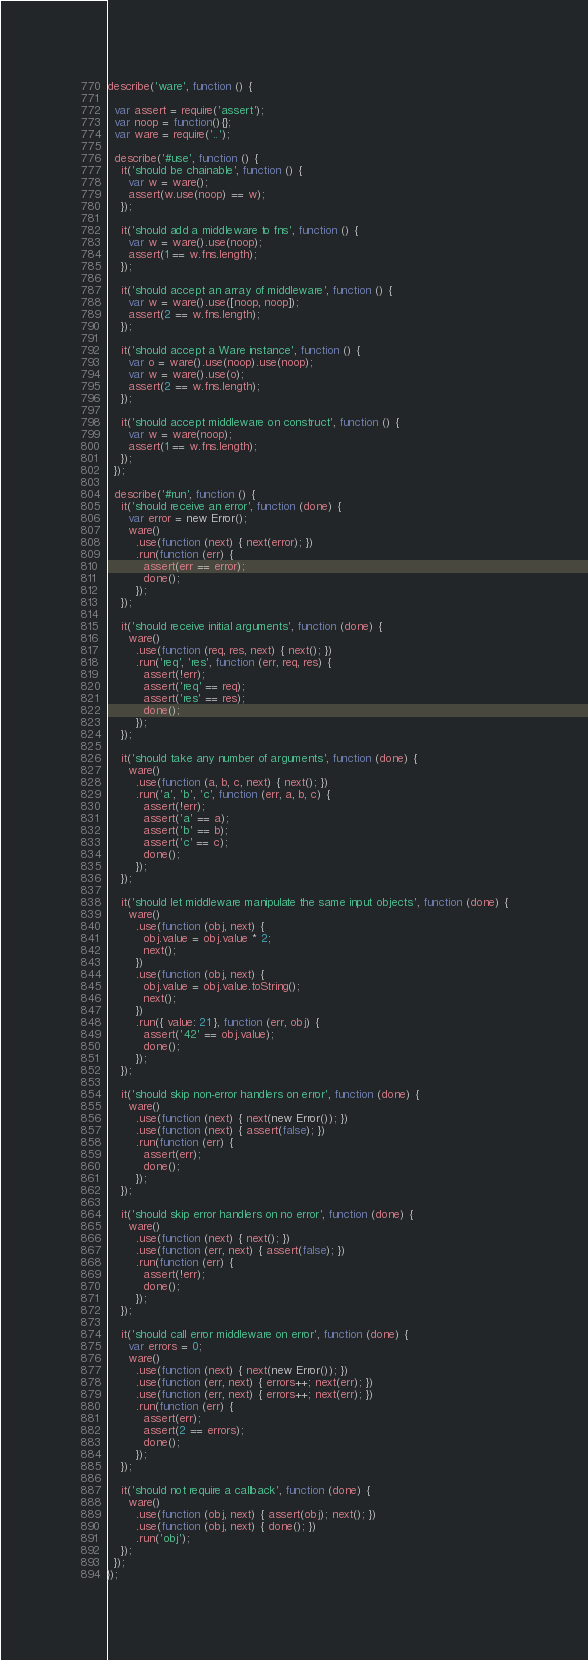<code> <loc_0><loc_0><loc_500><loc_500><_JavaScript_>
describe('ware', function () {

  var assert = require('assert');
  var noop = function(){};
  var ware = require('..');

  describe('#use', function () {
    it('should be chainable', function () {
      var w = ware();
      assert(w.use(noop) == w);
    });

    it('should add a middleware to fns', function () {
      var w = ware().use(noop);
      assert(1 == w.fns.length);
    });

    it('should accept an array of middleware', function () {
      var w = ware().use([noop, noop]);
      assert(2 == w.fns.length);
    });

    it('should accept a Ware instance', function () {
      var o = ware().use(noop).use(noop);
      var w = ware().use(o);
      assert(2 == w.fns.length);
    });

    it('should accept middleware on construct', function () {
      var w = ware(noop);
      assert(1 == w.fns.length);
    });
  });

  describe('#run', function () {
    it('should receive an error', function (done) {
      var error = new Error();
      ware()
        .use(function (next) { next(error); })
        .run(function (err) {
          assert(err == error);
          done();
        });
    });

    it('should receive initial arguments', function (done) {
      ware()
        .use(function (req, res, next) { next(); })
        .run('req', 'res', function (err, req, res) {
          assert(!err);
          assert('req' == req);
          assert('res' == res);
          done();
        });
    });

    it('should take any number of arguments', function (done) {
      ware()
        .use(function (a, b, c, next) { next(); })
        .run('a', 'b', 'c', function (err, a, b, c) {
          assert(!err);
          assert('a' == a);
          assert('b' == b);
          assert('c' == c);
          done();
        });
    });

    it('should let middleware manipulate the same input objects', function (done) {
      ware()
        .use(function (obj, next) {
          obj.value = obj.value * 2;
          next();
        })
        .use(function (obj, next) {
          obj.value = obj.value.toString();
          next();
        })
        .run({ value: 21 }, function (err, obj) {
          assert('42' == obj.value);
          done();
        });
    });

    it('should skip non-error handlers on error', function (done) {
      ware()
        .use(function (next) { next(new Error()); })
        .use(function (next) { assert(false); })
        .run(function (err) {
          assert(err);
          done();
        });
    });

    it('should skip error handlers on no error', function (done) {
      ware()
        .use(function (next) { next(); })
        .use(function (err, next) { assert(false); })
        .run(function (err) {
          assert(!err);
          done();
        });
    });

    it('should call error middleware on error', function (done) {
      var errors = 0;
      ware()
        .use(function (next) { next(new Error()); })
        .use(function (err, next) { errors++; next(err); })
        .use(function (err, next) { errors++; next(err); })
        .run(function (err) {
          assert(err);
          assert(2 == errors);
          done();
        });
    });

    it('should not require a callback', function (done) {
      ware()
        .use(function (obj, next) { assert(obj); next(); })
        .use(function (obj, next) { done(); })
        .run('obj');
    });
  });
});</code> 